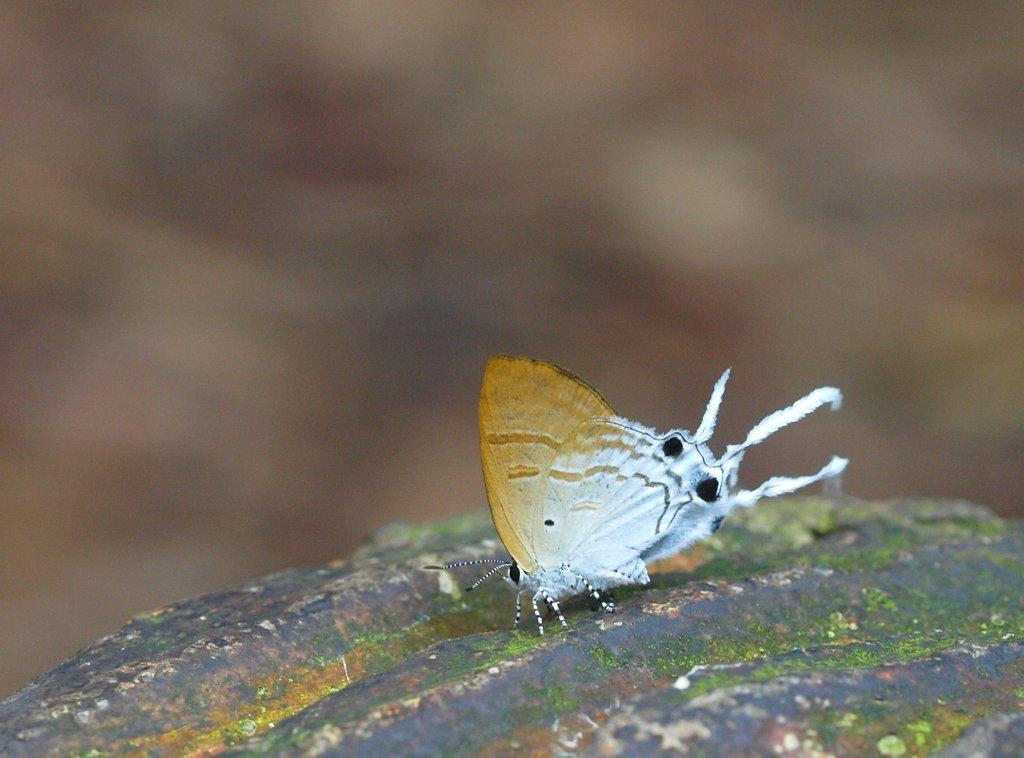Can you describe this image briefly? It is a butterfly in brown and white color in this image. 